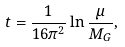Convert formula to latex. <formula><loc_0><loc_0><loc_500><loc_500>t = \frac { 1 } { 1 6 \pi ^ { 2 } } \ln \frac { \mu } { M _ { G } } ,</formula> 